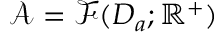Convert formula to latex. <formula><loc_0><loc_0><loc_500><loc_500>\mathcal { A } = \mathcal { F } ( D _ { a } ; \mathbb { R } ^ { + } )</formula> 